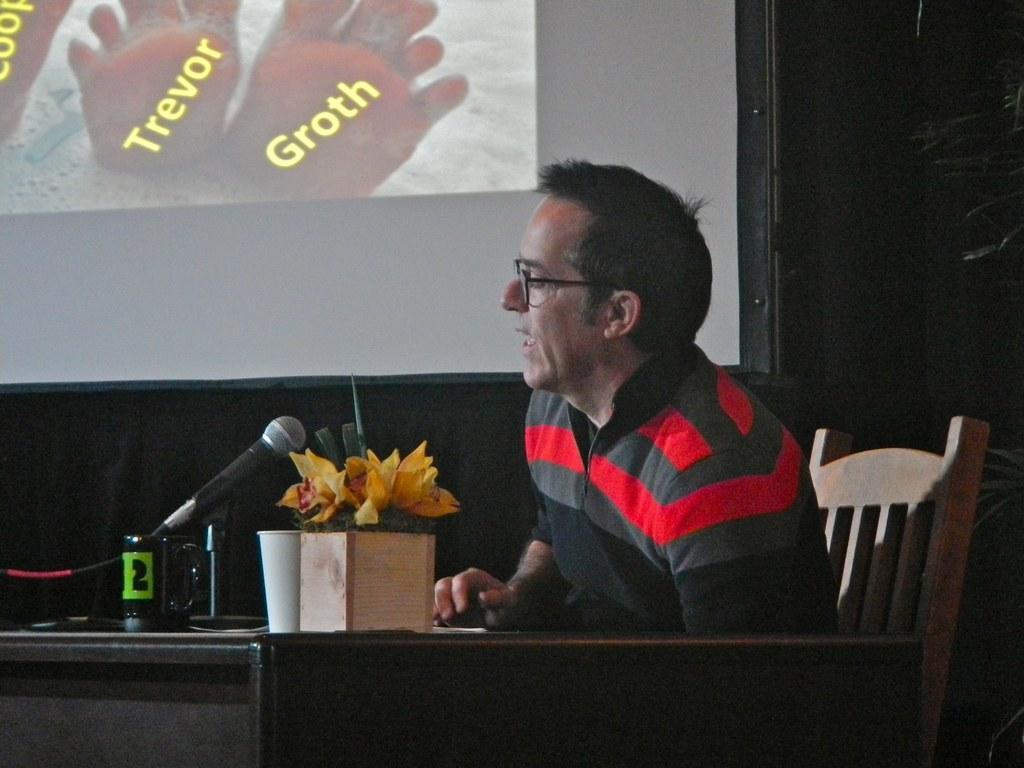Please provide a concise description of this image. In this picture there is a man who is sitting on the chair in the center of the image and there is a table in front of him, on which there is a mic and flower vase, there is a projector screen in the background area of the image. 